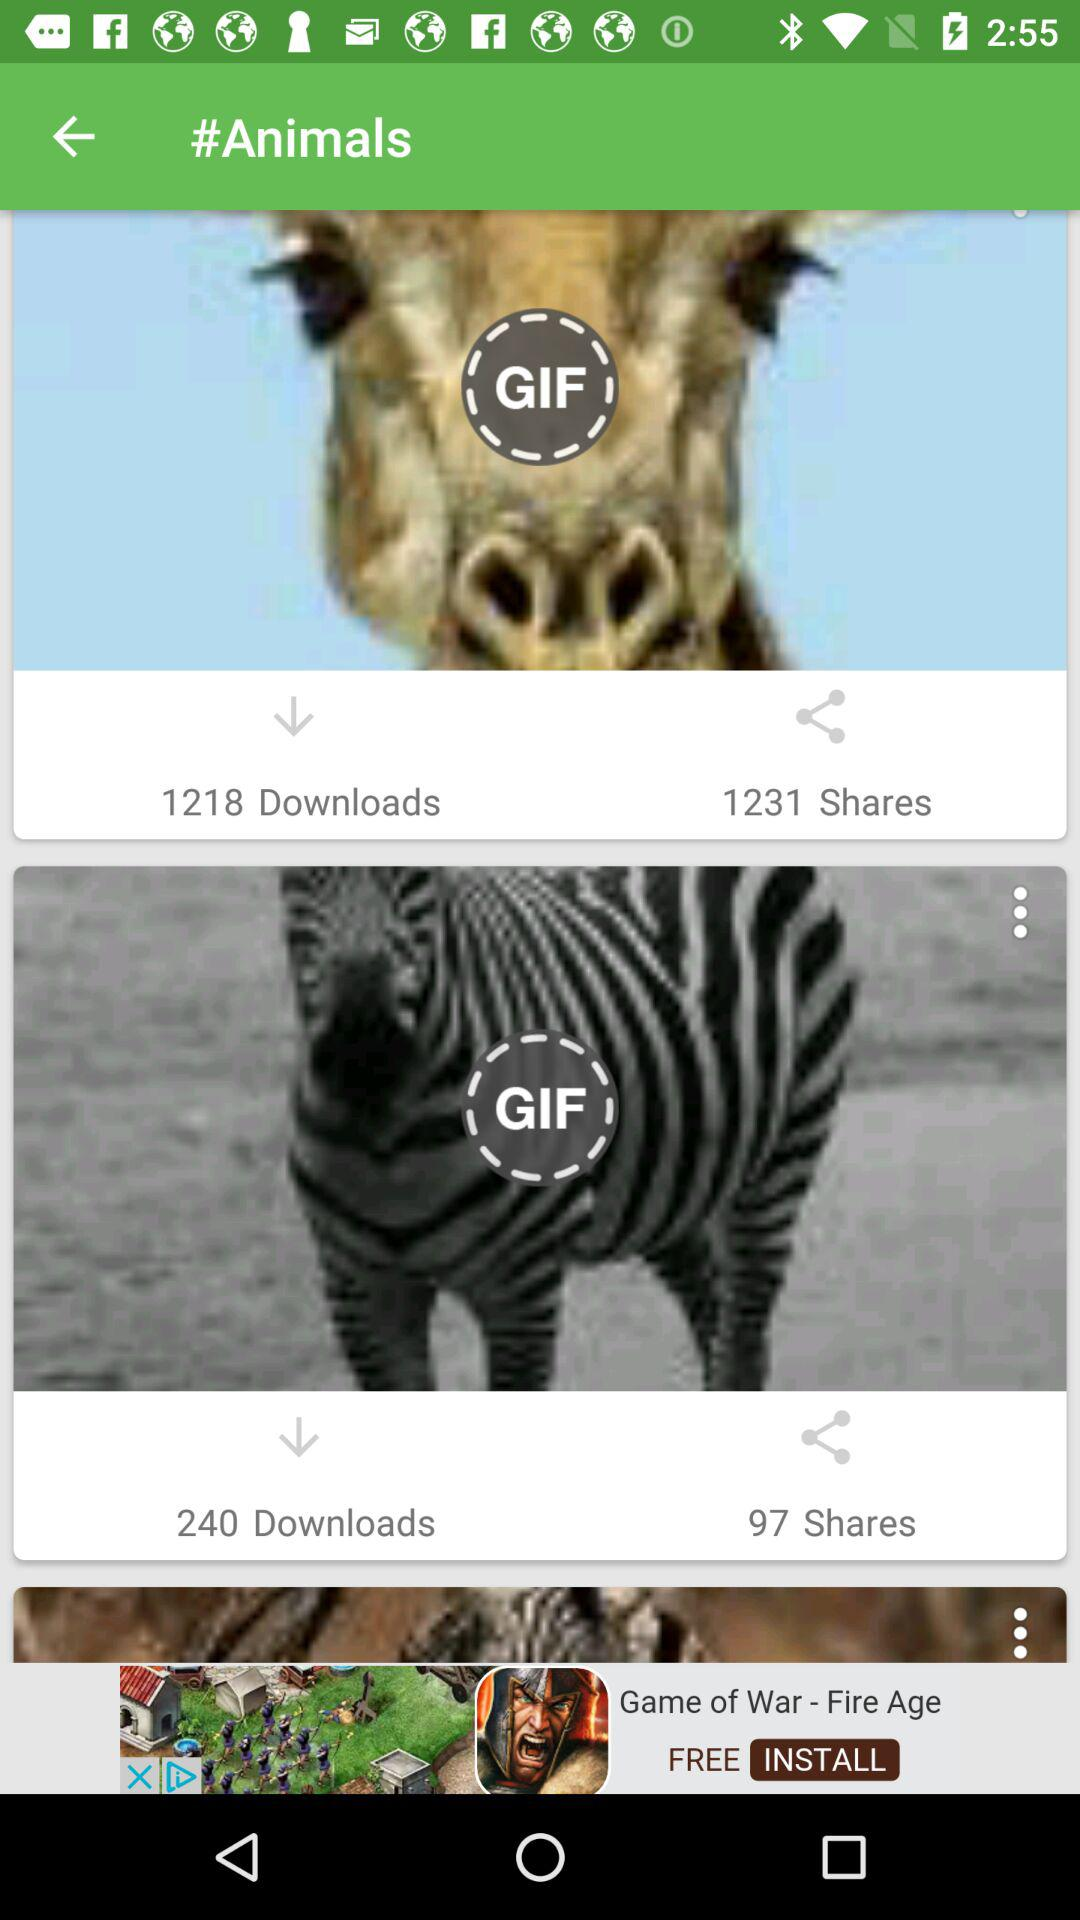How many people have shared the zebra GIF? The number of people who have shared the zebra GIF is 97. 